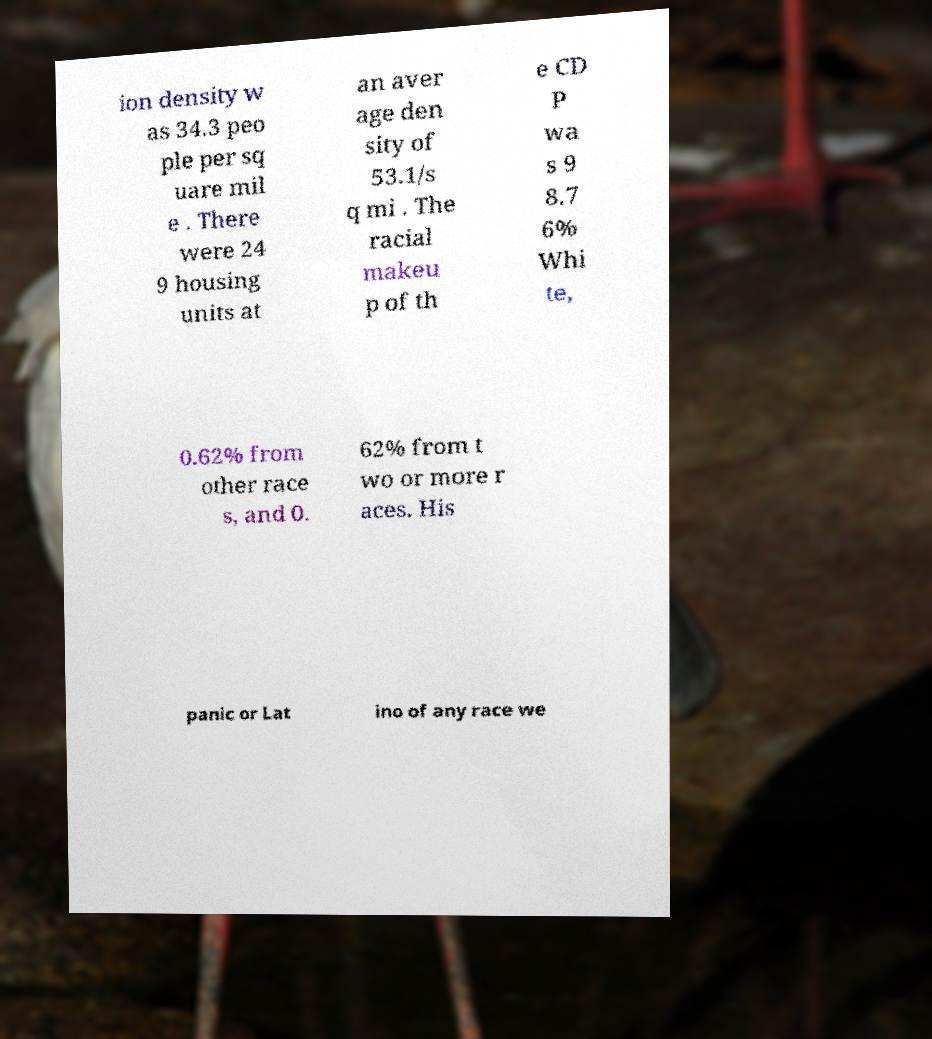Can you accurately transcribe the text from the provided image for me? ion density w as 34.3 peo ple per sq uare mil e . There were 24 9 housing units at an aver age den sity of 53.1/s q mi . The racial makeu p of th e CD P wa s 9 8.7 6% Whi te, 0.62% from other race s, and 0. 62% from t wo or more r aces. His panic or Lat ino of any race we 